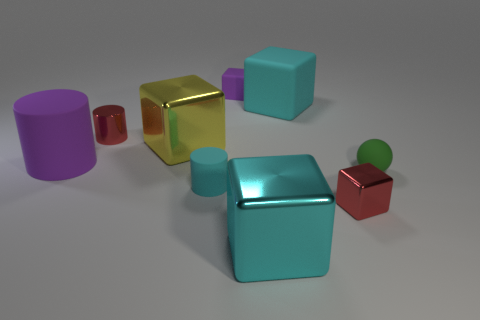Subtract all large purple rubber cylinders. How many cylinders are left? 2 Subtract all yellow cubes. How many cubes are left? 4 Subtract 1 spheres. How many spheres are left? 0 Add 1 large cyan matte blocks. How many objects exist? 10 Subtract all blue cylinders. Subtract all brown spheres. How many cylinders are left? 3 Add 6 purple cylinders. How many purple cylinders are left? 7 Add 3 tiny red cubes. How many tiny red cubes exist? 4 Subtract 1 green balls. How many objects are left? 8 Subtract all blocks. How many objects are left? 4 Subtract all cyan cylinders. How many gray balls are left? 0 